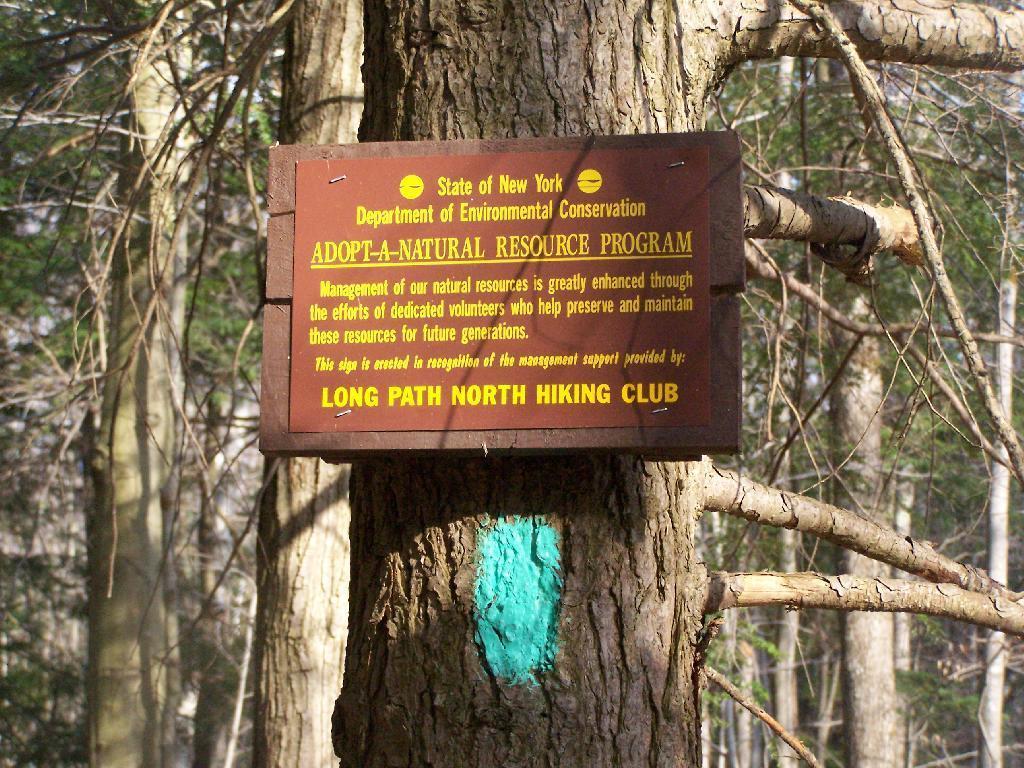In one or two sentences, can you explain what this image depicts? In this image, we can see a poster on the wooden board. Here there is a tree trunk. In the background we can see so many trees. 